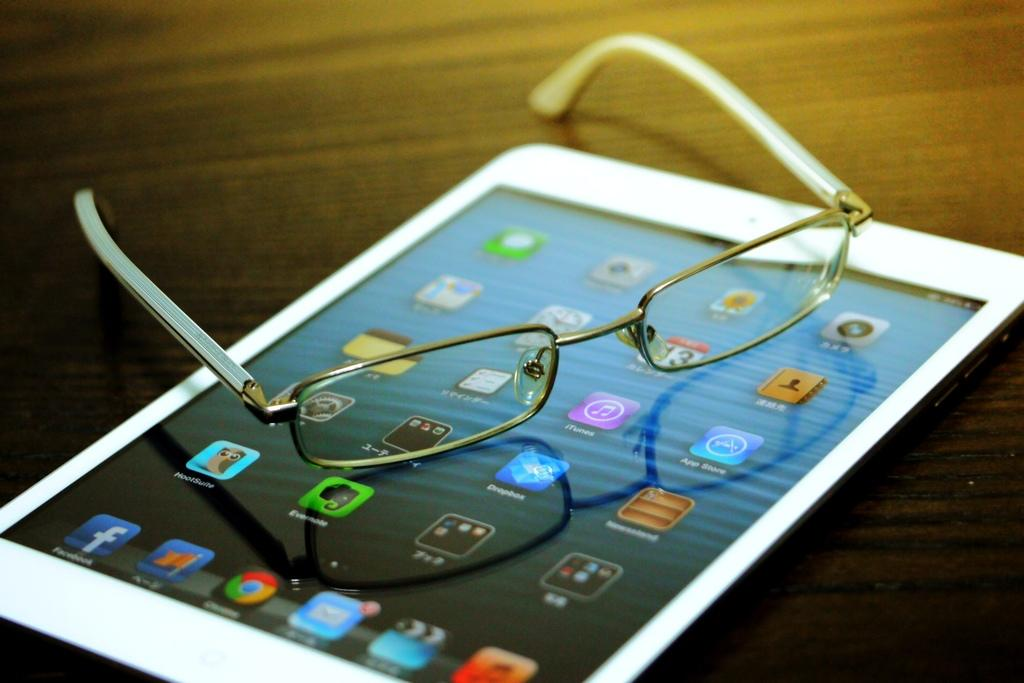What object is present on the table in the image? There is a tab on the table in the image. What can be seen on the tab? The tab has visible apps and text. Are there any other objects on the table besides the tab? Yes, there are spectacles on the table. What type of rat can be seen interacting with the tab in the image? There is no rat present in the image; it only features a tab on a table with spectacles. What type of memory is stored in the tab in the image? The image does not provide information about the type of memory stored in the tab. 